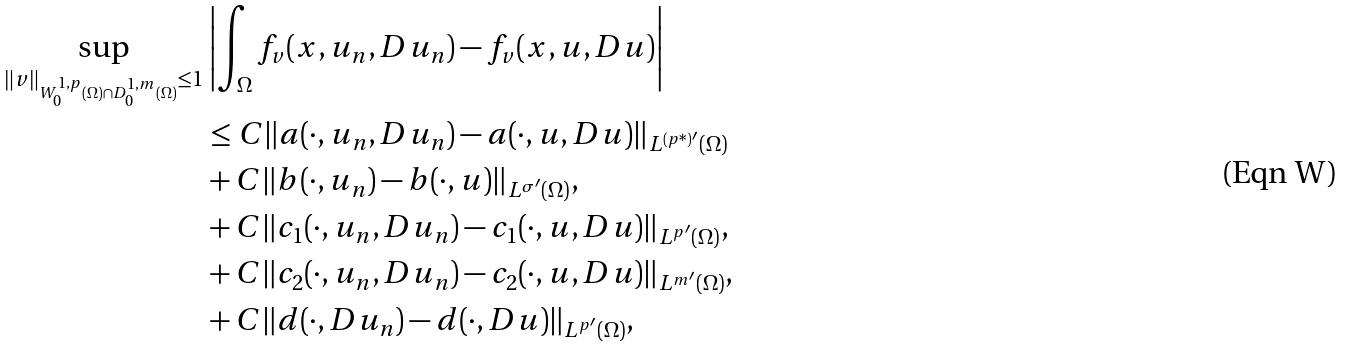<formula> <loc_0><loc_0><loc_500><loc_500>\sup _ { \| v \| _ { W ^ { 1 , p } _ { 0 } ( \Omega ) \cap D ^ { 1 , m } _ { 0 } ( \Omega ) } \leq 1 } & \left | \int _ { \Omega } f _ { v } ( x , u _ { n } , D u _ { n } ) - f _ { v } ( x , u , D u ) \right | \\ & \leq C \| a ( \cdot , u _ { n } , D u _ { n } ) - a ( \cdot , u , D u ) \| _ { L ^ { ( p ^ { * } ) ^ { \prime } } ( \Omega ) } \\ & + C \| b ( \cdot , u _ { n } ) - b ( \cdot , u ) \| _ { L ^ { \sigma ^ { \prime } } ( \Omega ) } , \\ & + C \| c _ { 1 } ( \cdot , u _ { n } , D u _ { n } ) - c _ { 1 } ( \cdot , u , D u ) \| _ { L ^ { p ^ { \prime } } ( \Omega ) } , \\ & + C \| c _ { 2 } ( \cdot , u _ { n } , D u _ { n } ) - c _ { 2 } ( \cdot , u , D u ) \| _ { L ^ { m ^ { \prime } } ( \Omega ) } , \\ & + C \| d ( \cdot , D u _ { n } ) - d ( \cdot , D u ) \| _ { L ^ { p ^ { \prime } } ( \Omega ) } ,</formula> 